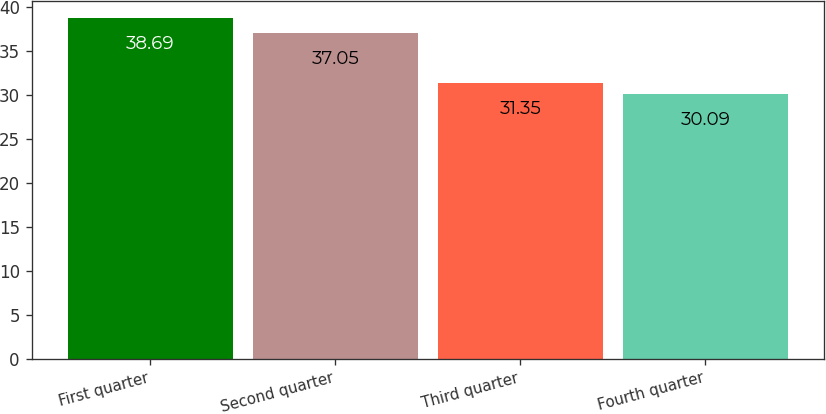<chart> <loc_0><loc_0><loc_500><loc_500><bar_chart><fcel>First quarter<fcel>Second quarter<fcel>Third quarter<fcel>Fourth quarter<nl><fcel>38.69<fcel>37.05<fcel>31.35<fcel>30.09<nl></chart> 